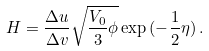Convert formula to latex. <formula><loc_0><loc_0><loc_500><loc_500>H = \frac { \Delta u } { \Delta v } \sqrt { \frac { V _ { 0 } } { 3 } \phi } \exp { ( - \frac { 1 } { 2 } \eta ) } \, .</formula> 